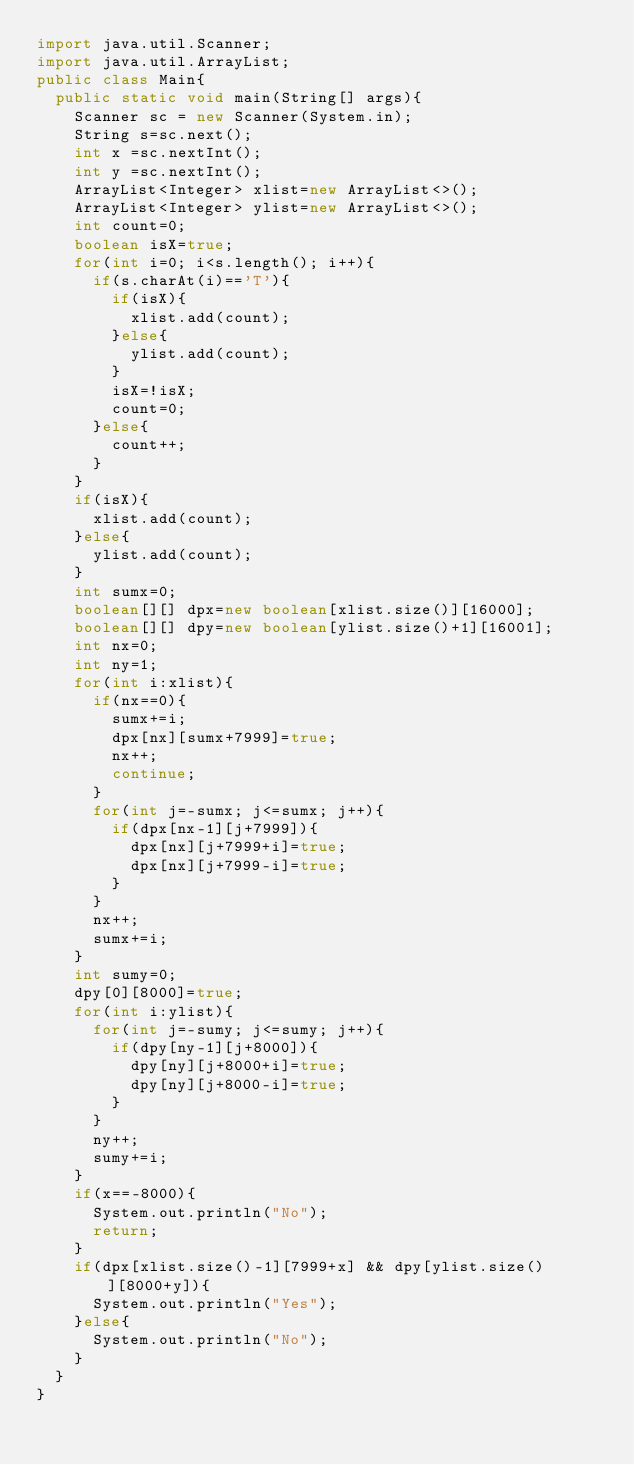<code> <loc_0><loc_0><loc_500><loc_500><_Java_>import java.util.Scanner;
import java.util.ArrayList;
public class Main{
	public static void main(String[] args){
		Scanner sc = new Scanner(System.in);
		String s=sc.next();
		int x =sc.nextInt();
		int y =sc.nextInt();
		ArrayList<Integer> xlist=new ArrayList<>();
		ArrayList<Integer> ylist=new ArrayList<>();
		int count=0;
		boolean isX=true;
		for(int i=0; i<s.length(); i++){
			if(s.charAt(i)=='T'){
				if(isX){
					xlist.add(count);
				}else{
					ylist.add(count);
				}
				isX=!isX;
				count=0;
			}else{
				count++;
			}
		}
		if(isX){
			xlist.add(count);
		}else{
			ylist.add(count);
		}
		int sumx=0;
		boolean[][] dpx=new boolean[xlist.size()][16000];
		boolean[][] dpy=new boolean[ylist.size()+1][16001];
		int nx=0;
		int ny=1;
		for(int i:xlist){
			if(nx==0){
				sumx+=i;
				dpx[nx][sumx+7999]=true;
				nx++;
				continue;
			}
			for(int j=-sumx; j<=sumx; j++){
				if(dpx[nx-1][j+7999]){
					dpx[nx][j+7999+i]=true;
					dpx[nx][j+7999-i]=true;
				}
			}
			nx++;
			sumx+=i;
		}
		int sumy=0;
		dpy[0][8000]=true;
		for(int i:ylist){
			for(int j=-sumy; j<=sumy; j++){
				if(dpy[ny-1][j+8000]){
					dpy[ny][j+8000+i]=true;
					dpy[ny][j+8000-i]=true;
				}
			}
			ny++;
			sumy+=i;
		}
		if(x==-8000){
			System.out.println("No");
			return;
		}
		if(dpx[xlist.size()-1][7999+x] && dpy[ylist.size()][8000+y]){
			System.out.println("Yes");
		}else{
			System.out.println("No");
		}
	}
}
</code> 